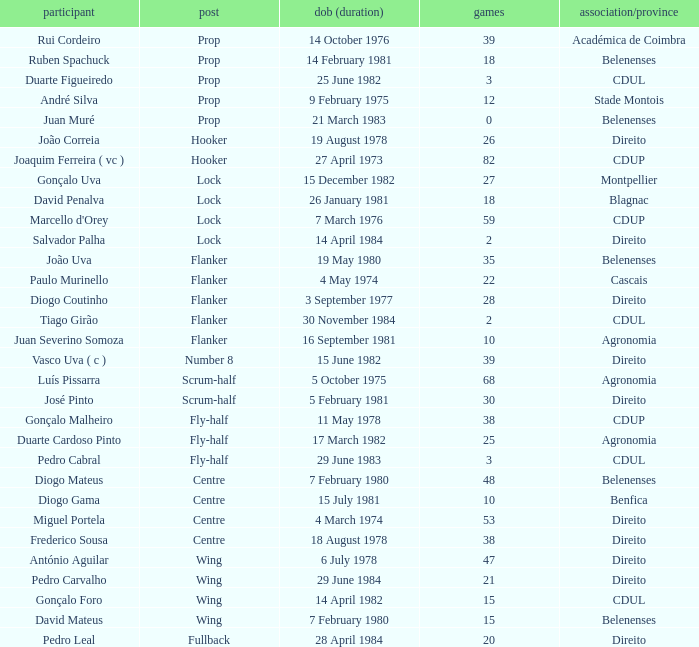Which player has a Club/province of direito, less than 21 caps, and a Position of lock? Salvador Palha. 